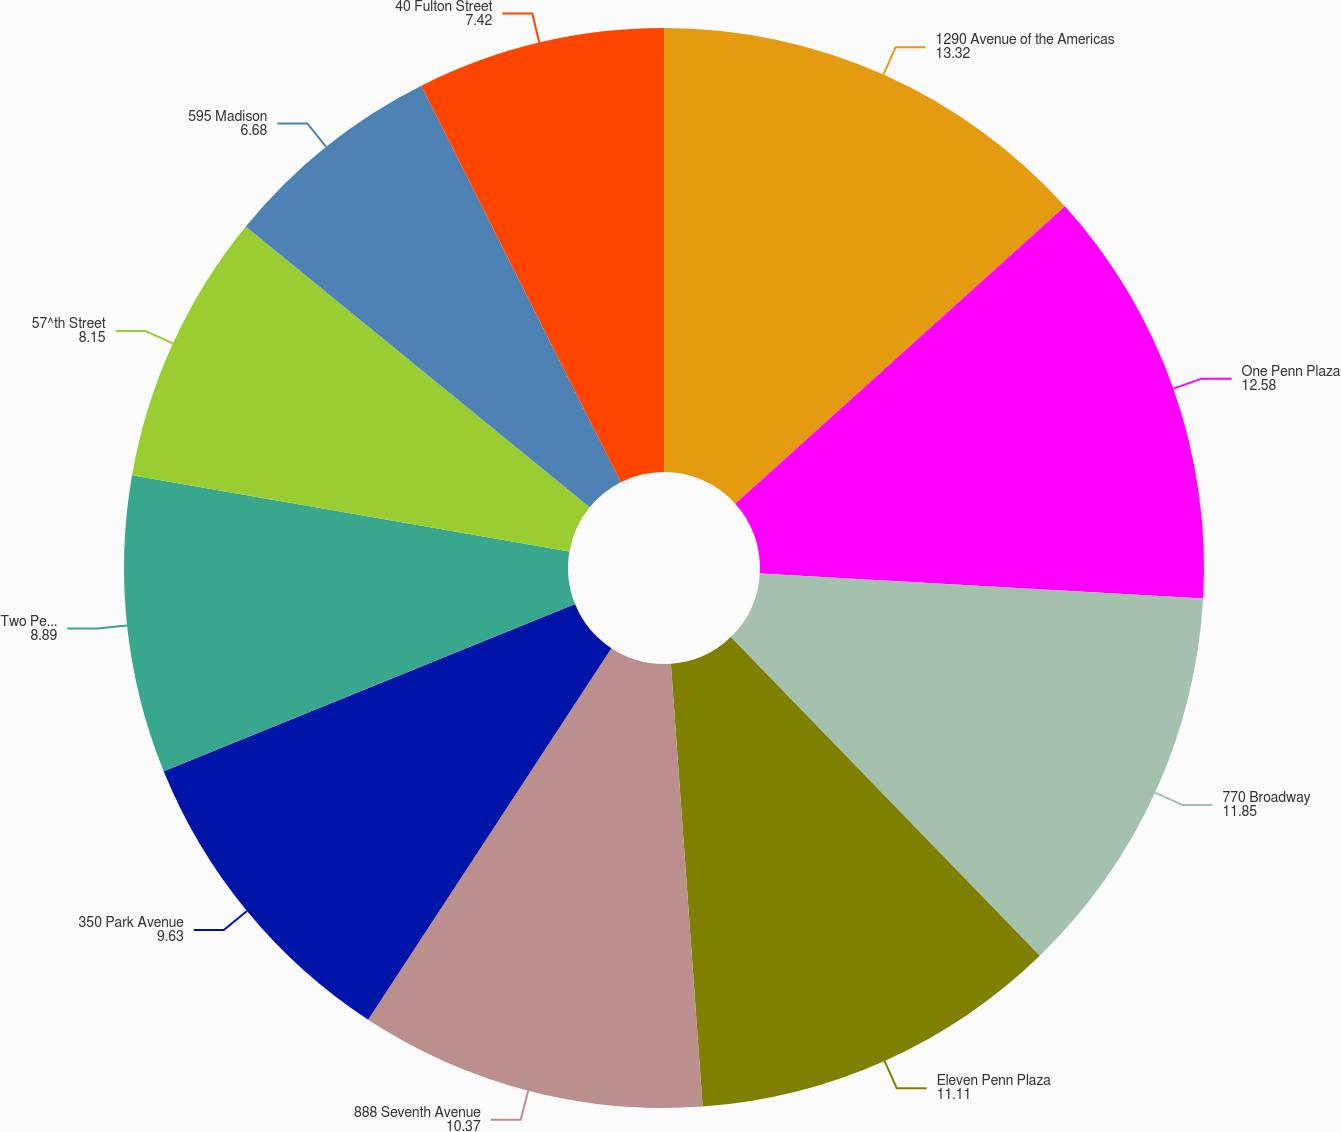Convert chart. <chart><loc_0><loc_0><loc_500><loc_500><pie_chart><fcel>1290 Avenue of the Americas<fcel>One Penn Plaza<fcel>770 Broadway<fcel>Eleven Penn Plaza<fcel>888 Seventh Avenue<fcel>350 Park Avenue<fcel>Two Penn Plaza<fcel>57^th Street<fcel>595 Madison<fcel>40 Fulton Street<nl><fcel>13.32%<fcel>12.58%<fcel>11.85%<fcel>11.11%<fcel>10.37%<fcel>9.63%<fcel>8.89%<fcel>8.15%<fcel>6.68%<fcel>7.42%<nl></chart> 